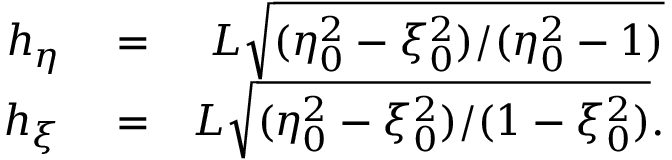Convert formula to latex. <formula><loc_0><loc_0><loc_500><loc_500>\begin{array} { r l r } { h _ { \eta } } & = } & { L \sqrt { ( \eta _ { 0 } ^ { 2 } - \xi _ { 0 } ^ { 2 } ) / ( \eta _ { 0 } ^ { 2 } - 1 ) } } \\ { h _ { \xi } } & = } & { L \sqrt { ( \eta _ { 0 } ^ { 2 } - \xi _ { 0 } ^ { 2 } ) / ( 1 - \xi _ { 0 } ^ { 2 } ) } . } \end{array}</formula> 